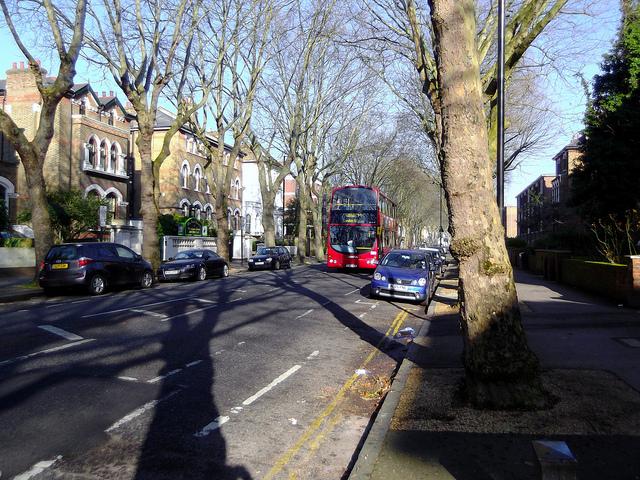Is it cold?
Answer briefly. Yes. What is in the picture?
Give a very brief answer. Bus. What color is the bus?
Quick response, please. Red. How many blue flags are there?
Keep it brief. 0. Do the trees have leaves on them?
Be succinct. No. What side of the road do the cars drive on?
Write a very short answer. Right. How old is this bus?
Short answer required. 2 years. 